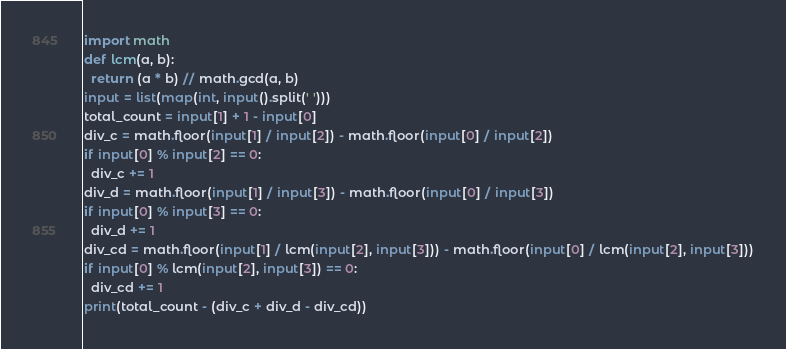Convert code to text. <code><loc_0><loc_0><loc_500><loc_500><_Python_>import math
def lcm(a, b):
  return (a * b) // math.gcd(a, b)
input = list(map(int, input().split(' ')))
total_count = input[1] + 1 - input[0]
div_c = math.floor(input[1] / input[2]) - math.floor(input[0] / input[2])
if input[0] % input[2] == 0:
  div_c += 1
div_d = math.floor(input[1] / input[3]) - math.floor(input[0] / input[3])
if input[0] % input[3] == 0:
  div_d += 1
div_cd = math.floor(input[1] / lcm(input[2], input[3])) - math.floor(input[0] / lcm(input[2], input[3]))
if input[0] % lcm(input[2], input[3]) == 0:
  div_cd += 1
print(total_count - (div_c + div_d - div_cd))</code> 